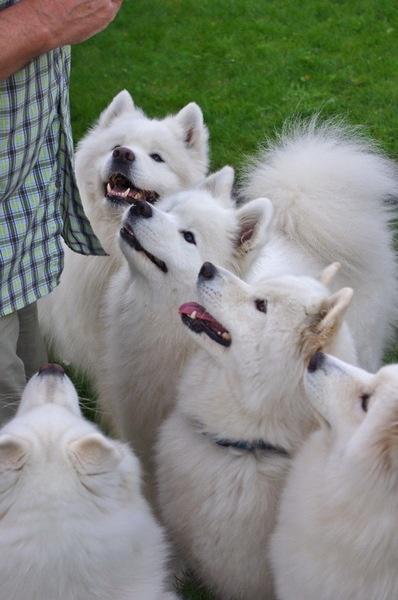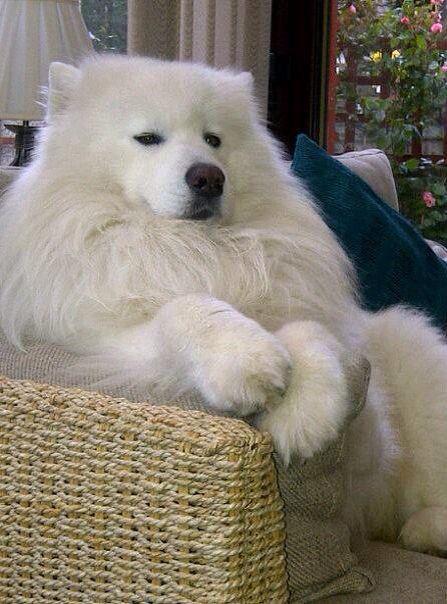The first image is the image on the left, the second image is the image on the right. Given the left and right images, does the statement "The left image contains a dog interacting with a rabbit." hold true? Answer yes or no. No. The first image is the image on the left, the second image is the image on the right. Considering the images on both sides, is "One image features a rabbit next to a dog." valid? Answer yes or no. No. 